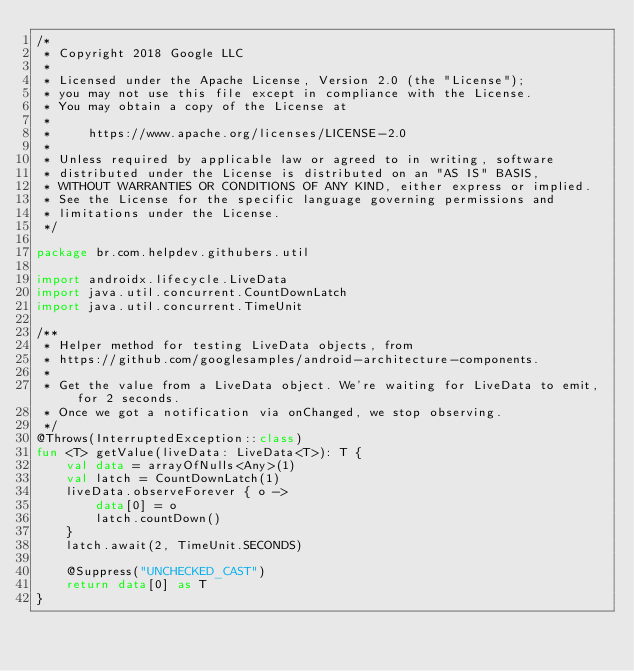<code> <loc_0><loc_0><loc_500><loc_500><_Kotlin_>/*
 * Copyright 2018 Google LLC
 *
 * Licensed under the Apache License, Version 2.0 (the "License");
 * you may not use this file except in compliance with the License.
 * You may obtain a copy of the License at
 *
 *     https://www.apache.org/licenses/LICENSE-2.0
 *
 * Unless required by applicable law or agreed to in writing, software
 * distributed under the License is distributed on an "AS IS" BASIS,
 * WITHOUT WARRANTIES OR CONDITIONS OF ANY KIND, either express or implied.
 * See the License for the specific language governing permissions and
 * limitations under the License.
 */

package br.com.helpdev.githubers.util

import androidx.lifecycle.LiveData
import java.util.concurrent.CountDownLatch
import java.util.concurrent.TimeUnit

/**
 * Helper method for testing LiveData objects, from
 * https://github.com/googlesamples/android-architecture-components.
 *
 * Get the value from a LiveData object. We're waiting for LiveData to emit, for 2 seconds.
 * Once we got a notification via onChanged, we stop observing.
 */
@Throws(InterruptedException::class)
fun <T> getValue(liveData: LiveData<T>): T {
    val data = arrayOfNulls<Any>(1)
    val latch = CountDownLatch(1)
    liveData.observeForever { o ->
        data[0] = o
        latch.countDown()
    }
    latch.await(2, TimeUnit.SECONDS)

    @Suppress("UNCHECKED_CAST")
    return data[0] as T
}
</code> 